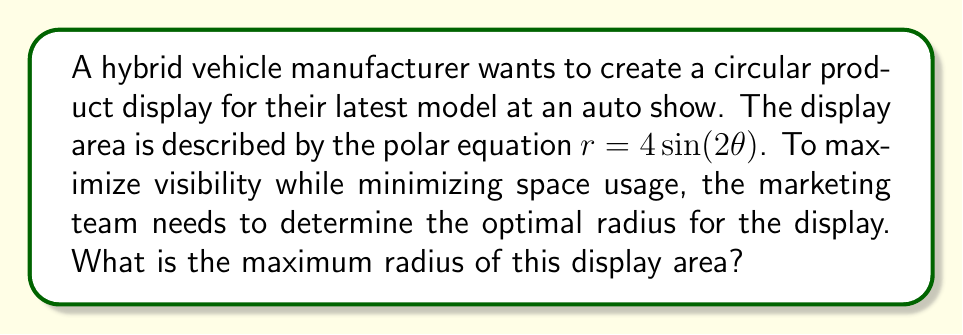Show me your answer to this math problem. To solve this problem, we need to follow these steps:

1) The polar equation given is $r = 4\sin(2\theta)$. This is a four-leaved rose curve.

2) To find the maximum radius, we need to find the maximum value of $r$.

3) In a rose curve, the maximum radius occurs when $\sin(2\theta)$ is at its maximum value, which is 1.

4) Therefore, the maximum radius is when:

   $r_{max} = 4\sin(2\theta) = 4(1) = 4$

5) We can verify this by plotting the curve:

[asy]
import graph;
size(200);
real r(real t) {return 4*sin(2*t);}
path g=polargraph(r,0,2pi);
draw(g,blue);
dot((4,0),red);
label("$r_{max}$", (2,0), E);
xaxis(Arrow);
yaxis(Arrow);
[/asy]

6) The red dot on the graph represents the maximum radius, which is indeed 4 units from the origin.

This maximum radius of 4 units provides the optimal size for the circular product display, balancing visibility and space efficiency for the hybrid vehicle showcase.
Answer: The maximum radius of the display area is 4 units. 